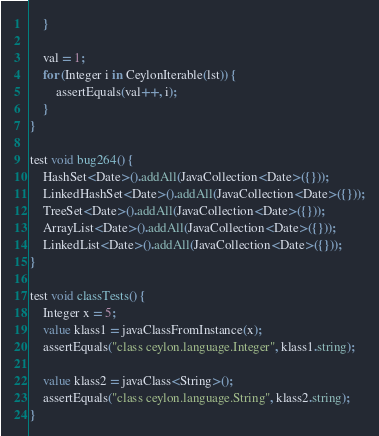<code> <loc_0><loc_0><loc_500><loc_500><_Ceylon_>    }
    
    val = 1;
    for (Integer i in CeylonIterable(lst)) {
        assertEquals(val++, i);
    }
}

test void bug264() {
    HashSet<Date>().addAll(JavaCollection<Date>({}));
    LinkedHashSet<Date>().addAll(JavaCollection<Date>({}));
    TreeSet<Date>().addAll(JavaCollection<Date>({}));
    ArrayList<Date>().addAll(JavaCollection<Date>({}));
    LinkedList<Date>().addAll(JavaCollection<Date>({}));
}

test void classTests() {
    Integer x = 5;
    value klass1 = javaClassFromInstance(x);
    assertEquals("class ceylon.language.Integer", klass1.string);
    
    value klass2 = javaClass<String>();
    assertEquals("class ceylon.language.String", klass2.string);
}
</code> 